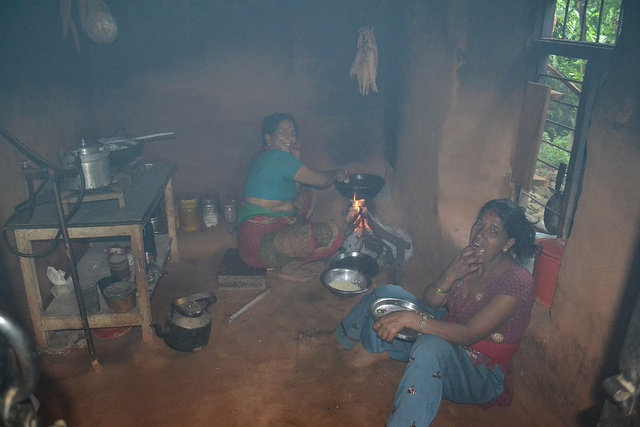Describe the objects in this image and their specific colors. I can see people in blue and gray tones, people in blue, gray, and teal tones, bowl in blue, gray, and darkgray tones, bowl in blue, darkgray, and white tones, and bottle in blue and gray tones in this image. 